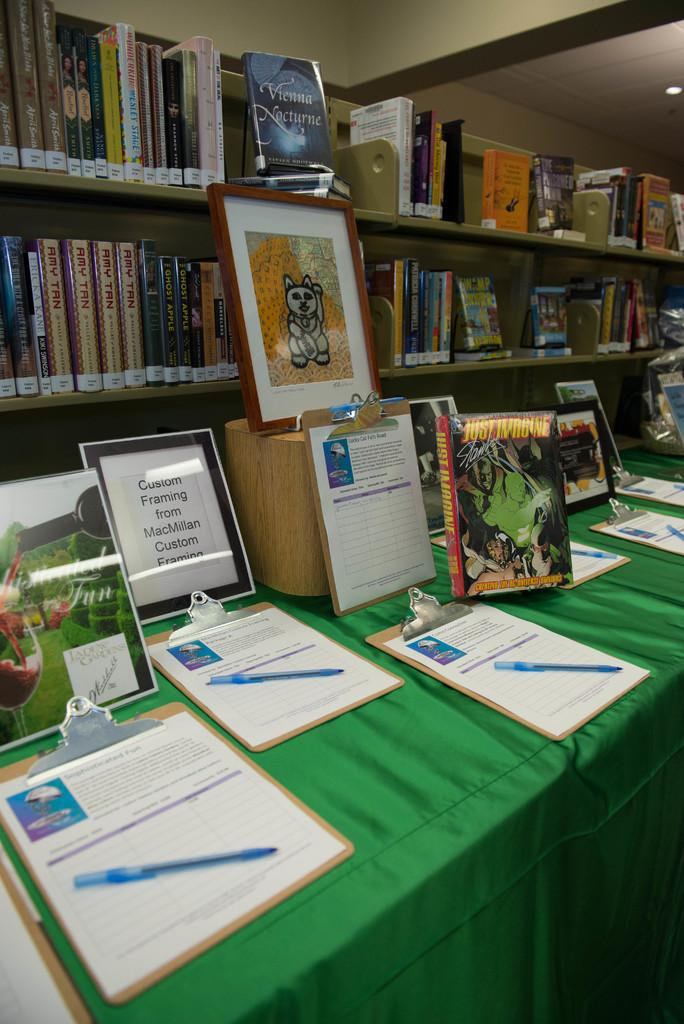<image>
Share a concise interpretation of the image provided. A table with some forms to be filled and a frame from MacMillan custom framing. 